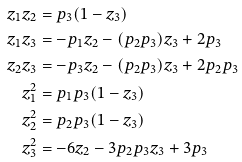<formula> <loc_0><loc_0><loc_500><loc_500>z _ { 1 } z _ { 2 } & = p _ { 3 } ( 1 - z _ { 3 } ) \\ z _ { 1 } z _ { 3 } & = - p _ { 1 } z _ { 2 } - ( p _ { 2 } p _ { 3 } ) z _ { 3 } + 2 p _ { 3 } \\ z _ { 2 } z _ { 3 } & = - p _ { 3 } z _ { 2 } - ( p _ { 2 } p _ { 3 } ) z _ { 3 } + 2 p _ { 2 } p _ { 3 } \\ z _ { 1 } ^ { 2 } & = p _ { 1 } p _ { 3 } ( 1 - z _ { 3 } ) \\ z _ { 2 } ^ { 2 } & = p _ { 2 } p _ { 3 } ( 1 - z _ { 3 } ) \\ z _ { 3 } ^ { 2 } & = - 6 z _ { 2 } - 3 p _ { 2 } p _ { 3 } z _ { 3 } + 3 p _ { 3 }</formula> 